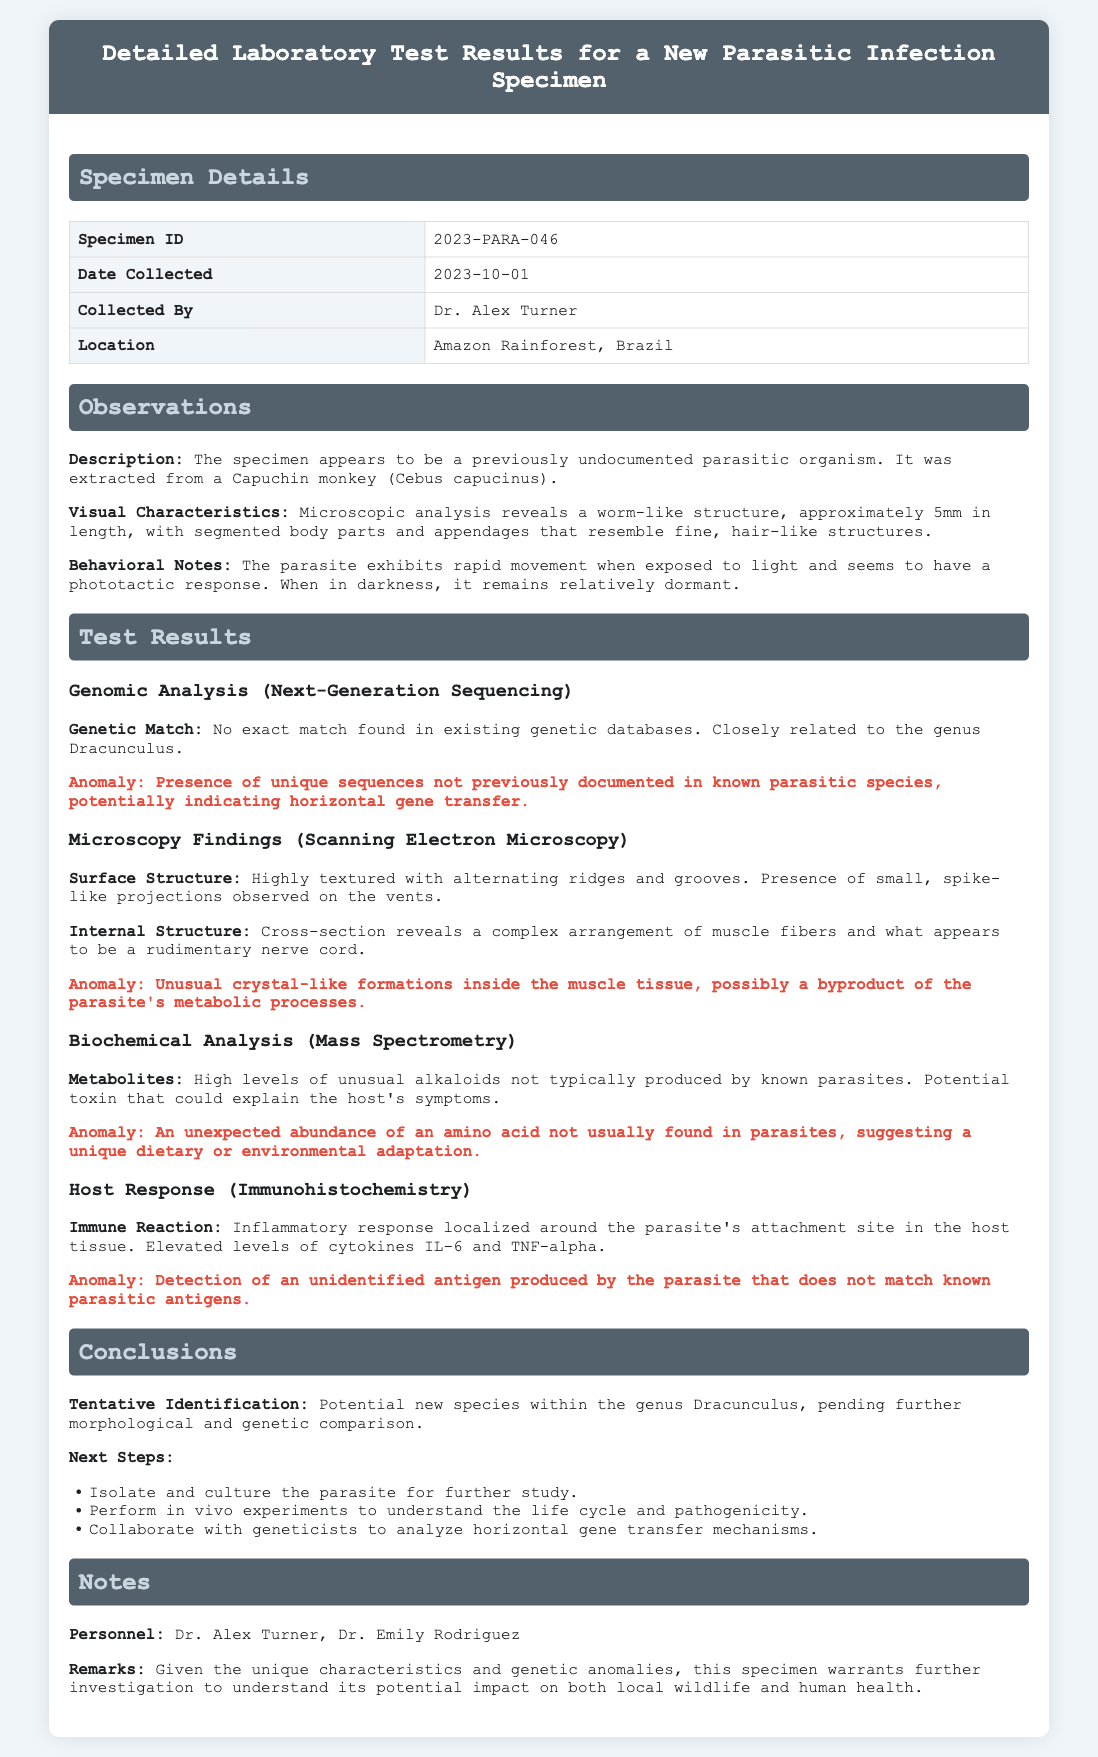What is the Specimen ID? The Specimen ID is a unique identifier for the organism being tested, which is mentioned in the Specimen Details section.
Answer: 2023-PARA-046 Who collected the specimen? The document specifies the name of the person who collected the specimen, found in the Specimen Details section.
Answer: Dr. Alex Turner Where was the specimen collected? The location of the specimen collection is provided in the Specimen Details section, which is relevant for environmental context.
Answer: Amazon Rainforest, Brazil What anomaly was detected in the genomic analysis? The document highlights a unique finding in the genomic analysis that is considered an anomaly, requiring attention.
Answer: Presence of unique sequences not previously documented in known parasitic species What are the elevated cytokines observed in the host response? The cytokines mentioned are specific markers of immune response observed in the laboratory tests, found in the Host Response section.
Answer: IL-6 and TNF-alpha What is the tentative identification of the specimen? The conclusion provides a tentative classification of the specimen based on current findings, indicating the status of research.
Answer: Potential new species within the genus Dracunculus What is one next step recommended for further study? The document outlines actions to be taken following the results, which is crucial for advancing research on the specimen.
Answer: Isolate and culture the parasite for further study What unique surface characteristics were observed under microscopy? The findings in the Microscopy section provide insight into the morphology of the specimen, important for its classification.
Answer: Highly textured with alternating ridges and grooves What kind of organism was the specimen extracted from? The origin of the specimen is noted, which can provide contextual understanding of the lifeform's host and habitat.
Answer: Capuchin monkey (Cebus capucinus) 